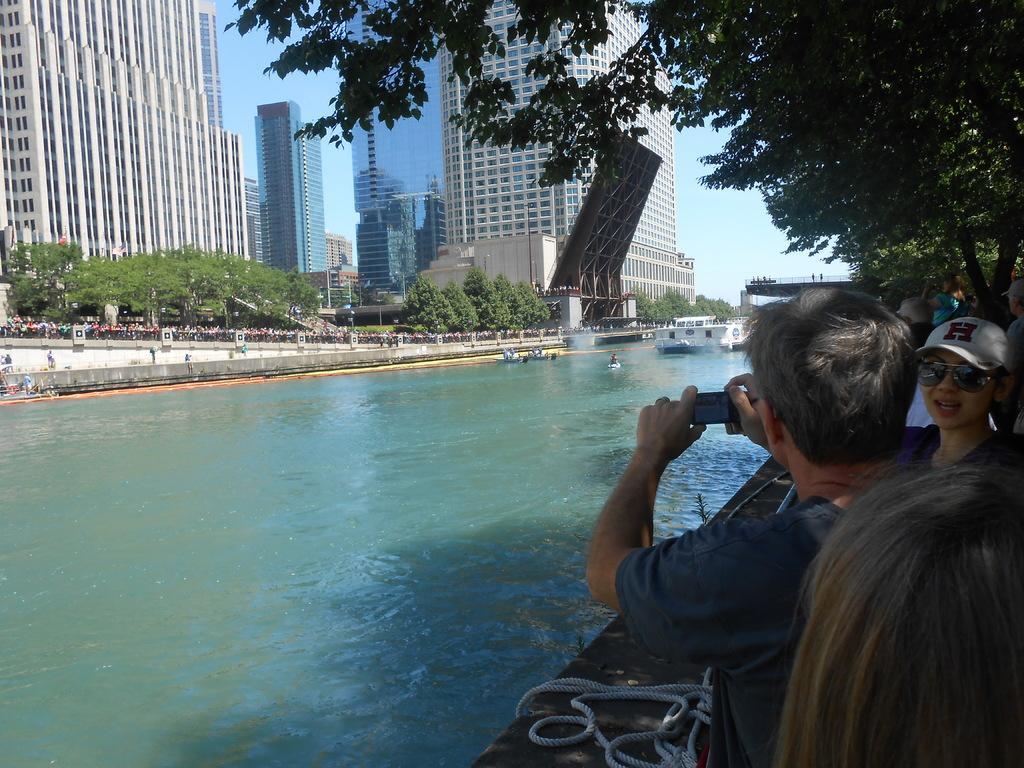Please provide a concise description of this image. This is the picture of a city. On the right side of the image there is a person standing and holding the camera and there are group of people standing. There is a rope on the wall and there are trees. On the left side of the image there are buildings and trees and there are group of people standing behind the railing. In the middle of the image there is a ship and there are boats on the water. At the top there is sky. At the bottom there is water. 